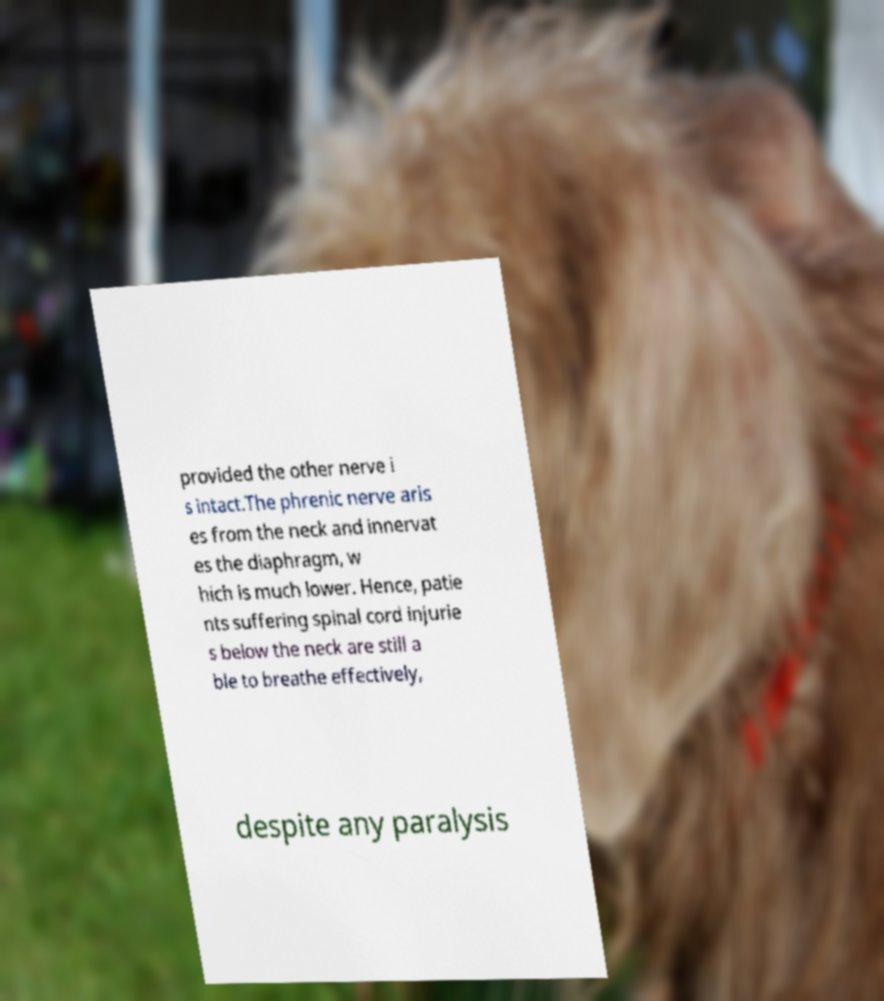Please identify and transcribe the text found in this image. provided the other nerve i s intact.The phrenic nerve aris es from the neck and innervat es the diaphragm, w hich is much lower. Hence, patie nts suffering spinal cord injurie s below the neck are still a ble to breathe effectively, despite any paralysis 